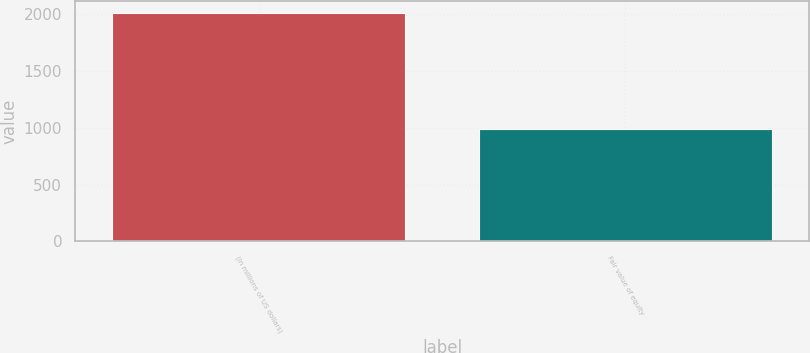Convert chart. <chart><loc_0><loc_0><loc_500><loc_500><bar_chart><fcel>(in millions of US dollars)<fcel>Fair value of equity<nl><fcel>2008<fcel>988<nl></chart> 